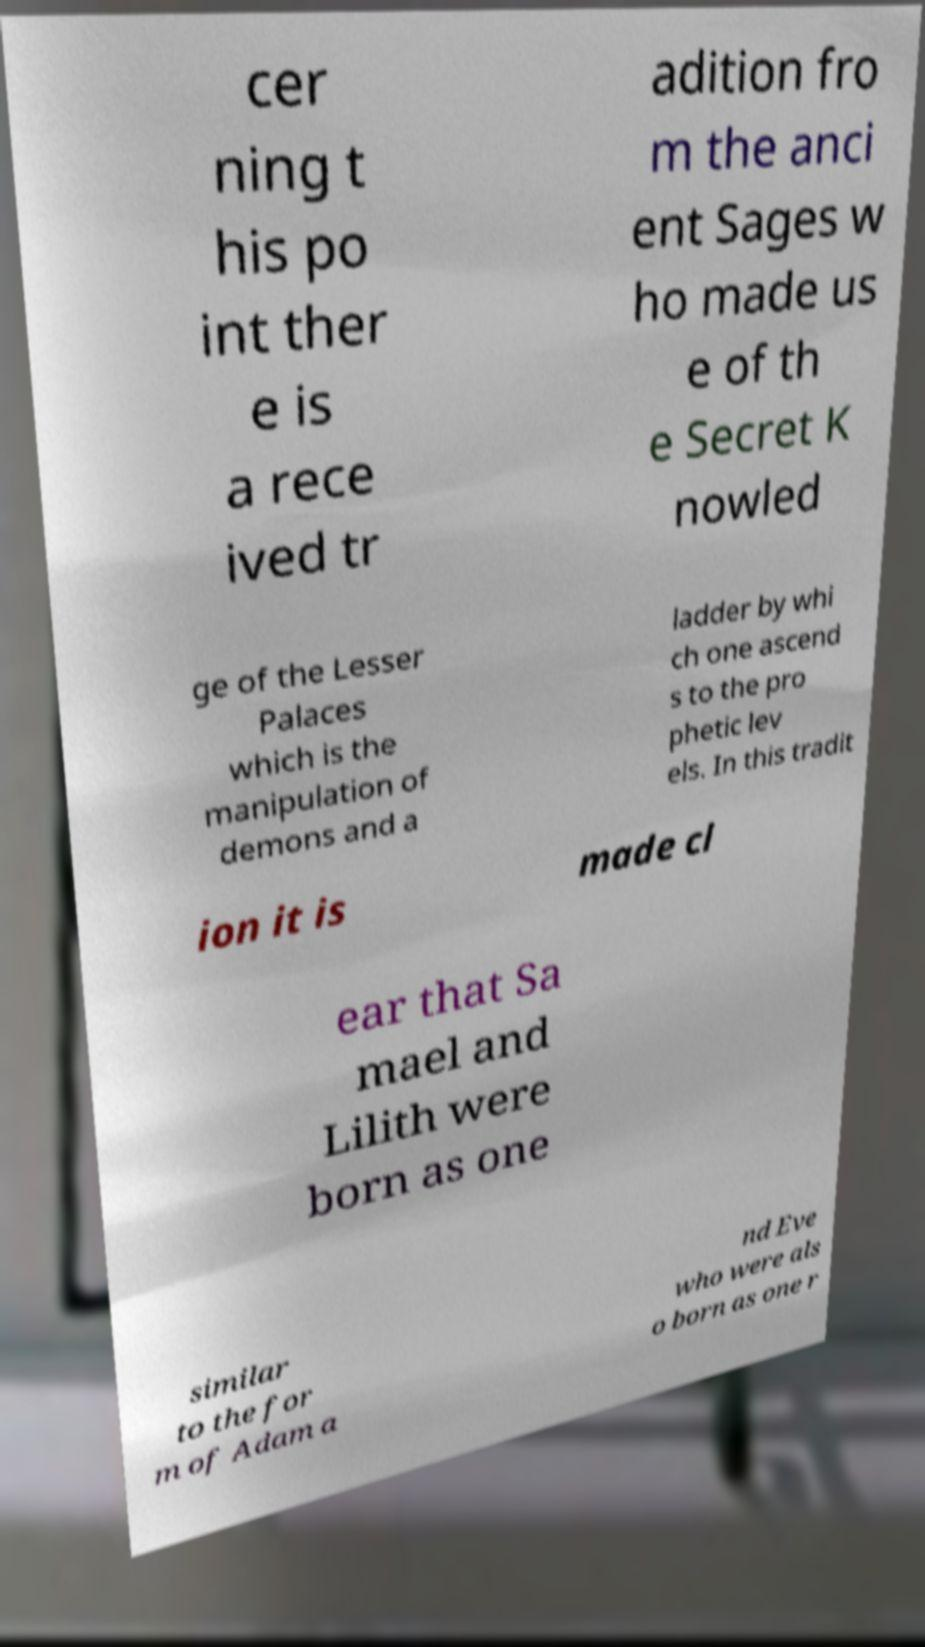What messages or text are displayed in this image? I need them in a readable, typed format. cer ning t his po int ther e is a rece ived tr adition fro m the anci ent Sages w ho made us e of th e Secret K nowled ge of the Lesser Palaces which is the manipulation of demons and a ladder by whi ch one ascend s to the pro phetic lev els. In this tradit ion it is made cl ear that Sa mael and Lilith were born as one similar to the for m of Adam a nd Eve who were als o born as one r 